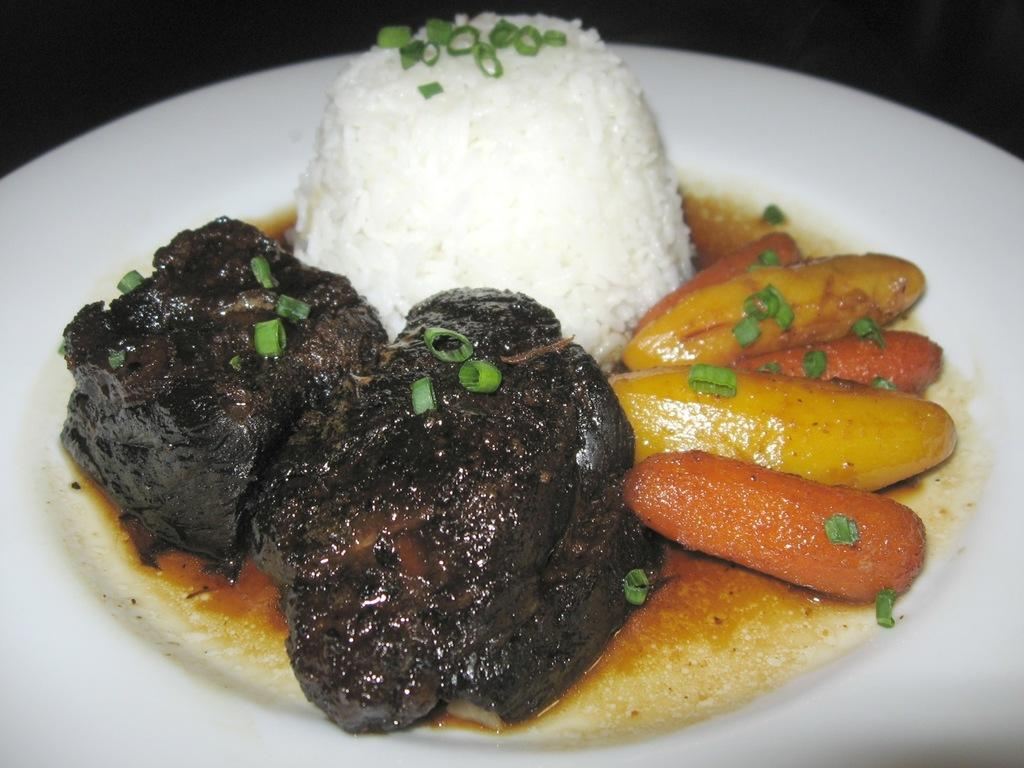What is the main object in the center of the image? There is a plate in the center of the image. What is on the plate? The plate contains dessert items. What type of beast can be seen walking on the sidewalk in the image? There is no beast or sidewalk present in the image; it only features a plate with dessert items. 